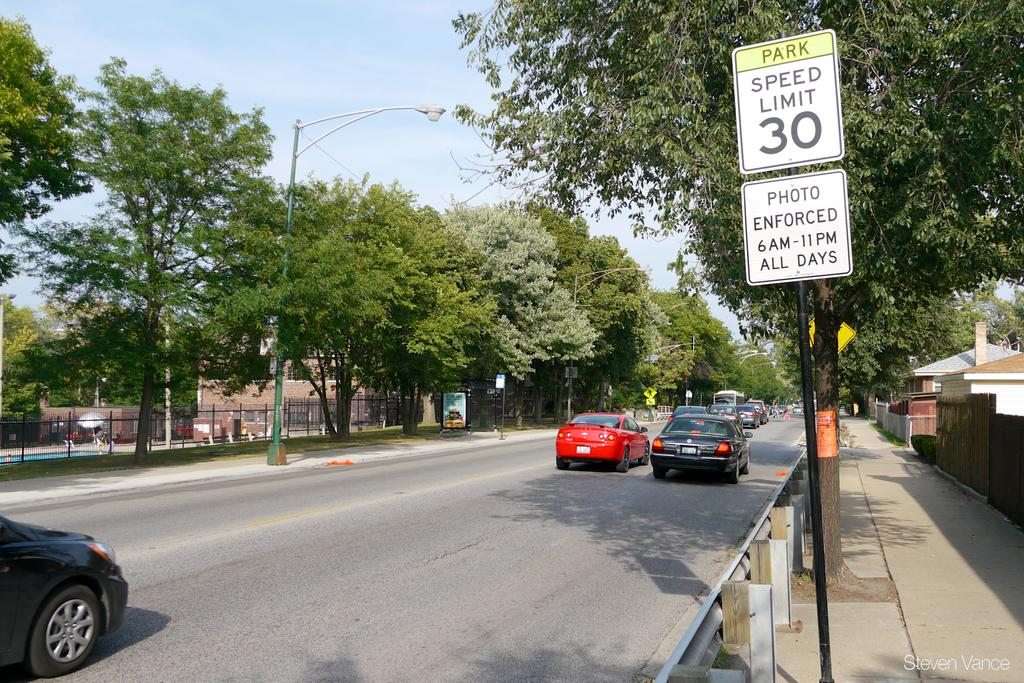<image>
Describe the image concisely. Cars travelling down a street with a 30 mile per hour speed limit. 